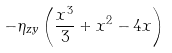Convert formula to latex. <formula><loc_0><loc_0><loc_500><loc_500>- \eta _ { z y } \left ( \frac { x ^ { 3 } } { 3 } + x ^ { 2 } - 4 x \right )</formula> 